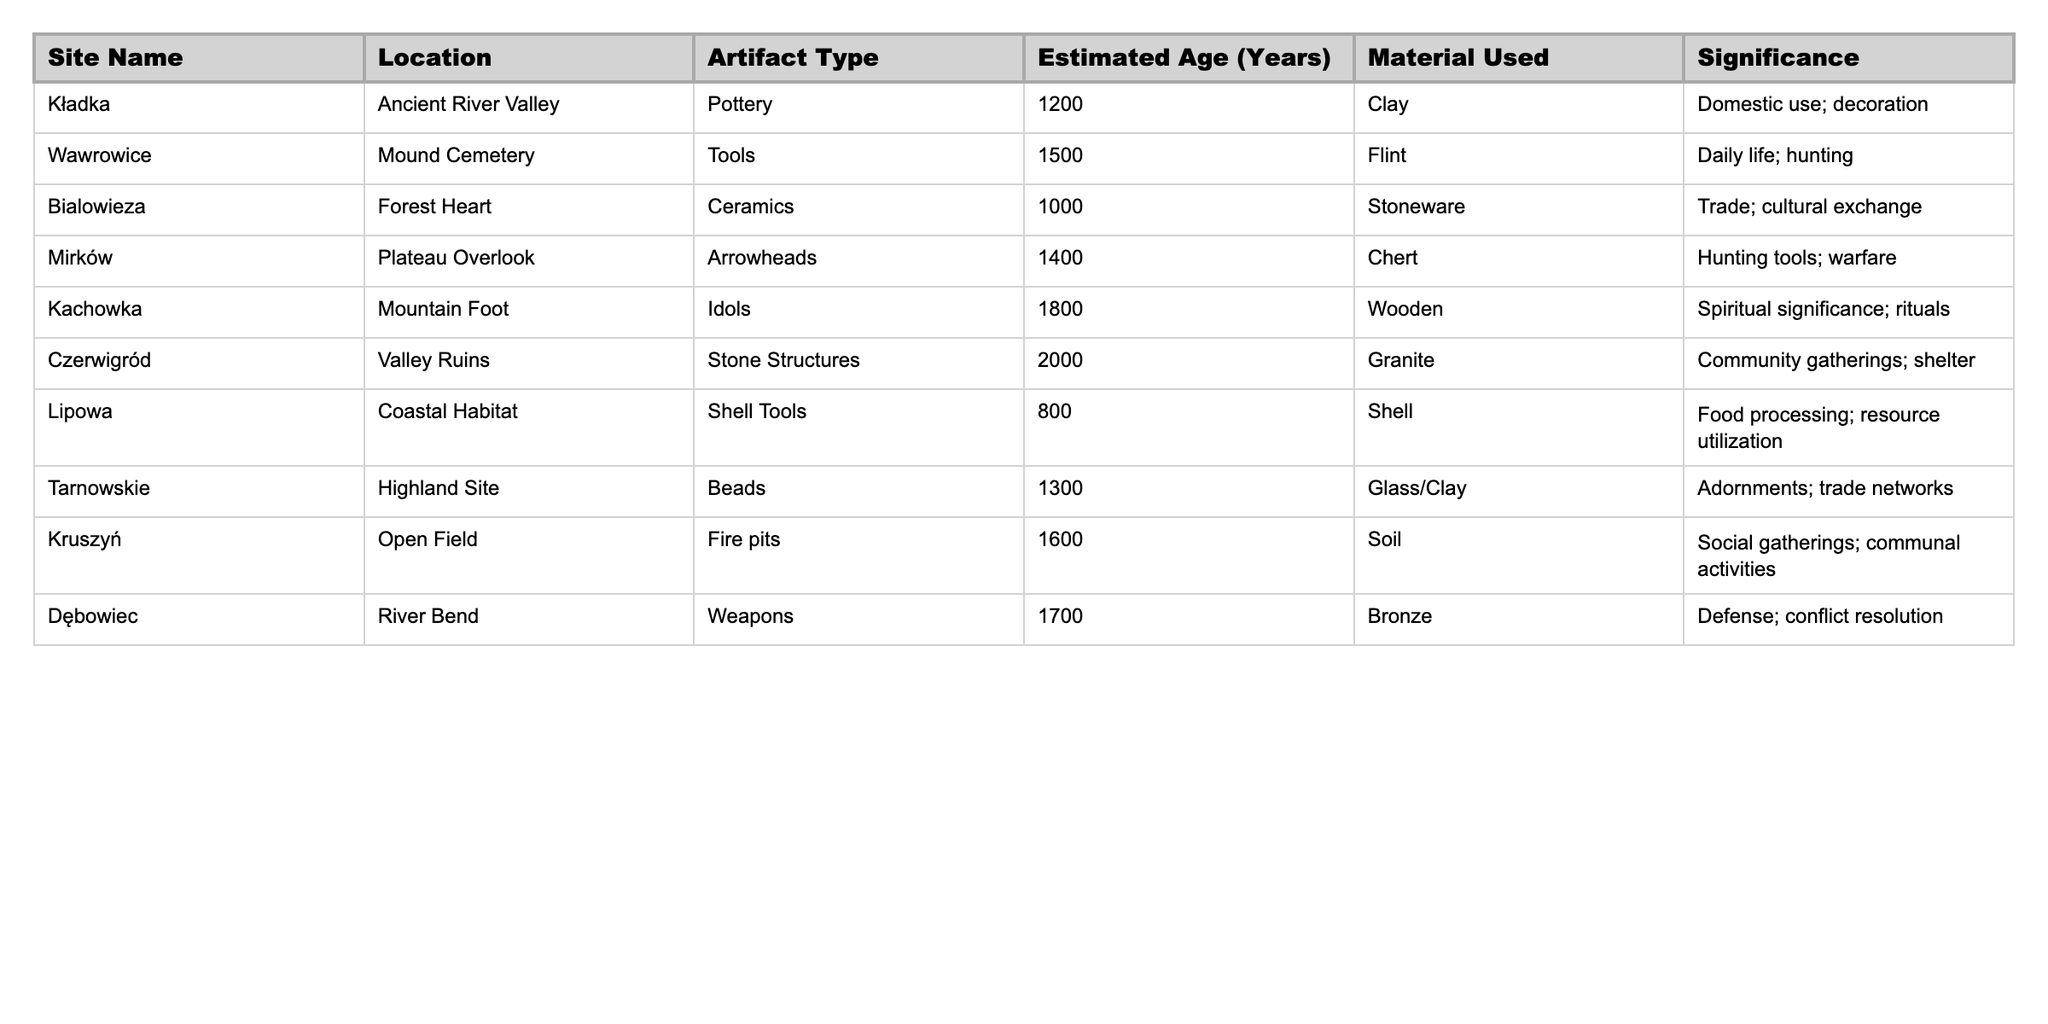What is the estimated age of the artifacts found at Kladka? The specified row for Kladka shows an estimated age of 1200 years in the "Estimated Age (Years)" column.
Answer: 1200 Which site has the oldest artifacts and what are they? The oldest artifacts are found at Czerwigród, with an estimated age of 2000 years, and the artifact type is "Stone Structures".
Answer: Czerwigród, Stone Structures What material is primarily used for the idols found at Kachowka? The table states that the material used for the idols at Kachowka is "Wooden".
Answer: Wooden How many sites have artifacts made from flint? The entry for Wawrowice is the only site listed with artifacts made from flint in the "Material Used" column, indicating there is only one site.
Answer: 1 What is the significance of the artifacts found at Mirków? The significance listed for Mirków's artifacts (Arrowheads) includes hunting tools and warfare, as per the "Significance" column.
Answer: Hunting tools; warfare Which two sites have artifacts related to community or social activities? In the table, Czerwigród (Stone Structures) is about community gatherings; Kružyn (Fire pits) relates to social gatherings, fulfilling the search criteria for both.
Answer: Czerwigród, Kruszyń What is the average estimated age of all the sites listed in the table? The sum of the estimated ages (1200 + 1500 + 1000 + 1400 + 1800 + 2000 + 800 + 1300 + 1600 + 1700) is 14600 years and there are 10 sites, hence the average is 14600/10 = 1460 years.
Answer: 1460 Are there artifacts from the coastal habitat region, and if so, what type are they? Lipowa is the site noted for coastal habitat region artifacts, characterized as "Shell Tools" in the "Artifact Type" column.
Answer: Yes, Shell Tools How many artifact types are used for trade purposes across the sites? The only artifacts mentioned for trade purposes are ceramics from Bialowieza and beads from Tarnowskie, resulting in a total of two distinct types related to trade.
Answer: 2 Which site with the highest estimated age also has a spiritual significance, and what is the artifact? Kachowka is the site with the highest estimated age (1800 years) that includes artifacts of spiritual significance, specifically idols.
Answer: Kachowka, Idols 